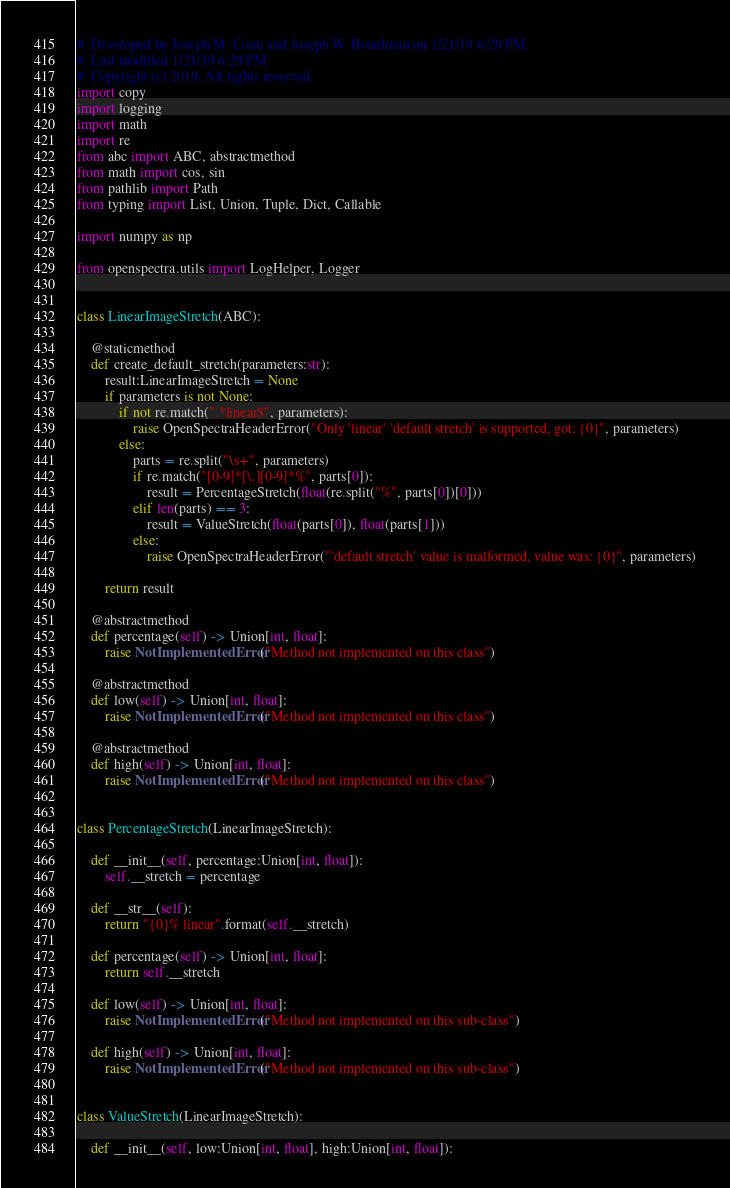Convert code to text. <code><loc_0><loc_0><loc_500><loc_500><_Python_>#  Developed by Joseph M. Conti and Joseph W. Boardman on 1/21/19 6:29 PM.
#  Last modified 1/21/19 6:29 PM
#  Copyright (c) 2019. All rights reserved.
import copy
import logging
import math
import re
from abc import ABC, abstractmethod
from math import cos, sin
from pathlib import Path
from typing import List, Union, Tuple, Dict, Callable

import numpy as np

from openspectra.utils import LogHelper, Logger


class LinearImageStretch(ABC):

    @staticmethod
    def create_default_stretch(parameters:str):
        result:LinearImageStretch = None
        if parameters is not None:
            if not re.match(".*linear$", parameters):
                raise OpenSpectraHeaderError("Only 'linear' 'default stretch' is supported, got: {0}", parameters)
            else:
                parts = re.split("\s+", parameters)
                if re.match("[0-9]*[\.][0-9]*%", parts[0]):
                    result = PercentageStretch(float(re.split("%", parts[0])[0]))
                elif len(parts) == 3:
                    result = ValueStretch(float(parts[0]), float(parts[1]))
                else:
                    raise OpenSpectraHeaderError("'default stretch' value is malformed, value was: {0}", parameters)

        return result

    @abstractmethod
    def percentage(self) -> Union[int, float]:
        raise NotImplementedError("Method not implemented on this class")

    @abstractmethod
    def low(self) -> Union[int, float]:
        raise NotImplementedError("Method not implemented on this class")

    @abstractmethod
    def high(self) -> Union[int, float]:
        raise NotImplementedError("Method not implemented on this class")


class PercentageStretch(LinearImageStretch):

    def __init__(self, percentage:Union[int, float]):
        self.__stretch = percentage

    def __str__(self):
        return "{0}% linear".format(self.__stretch)

    def percentage(self) -> Union[int, float]:
        return self.__stretch

    def low(self) -> Union[int, float]:
        raise NotImplementedError("Method not implemented on this sub-class")

    def high(self) -> Union[int, float]:
        raise NotImplementedError("Method not implemented on this sub-class")


class ValueStretch(LinearImageStretch):

    def __init__(self, low:Union[int, float], high:Union[int, float]):</code> 